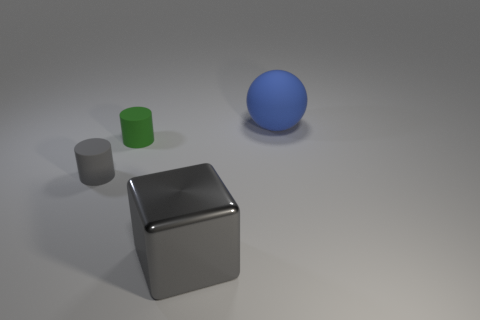Imagine these objects are part of a learning kit, what might be the purpose of this kit? If these objects are part of a learning kit, they could be used to help teach fundamental concepts such as geometry, understanding three-dimensional shapes, color recognition, and spatial reasoning. The kit can demonstrate how geometric forms are constructed and how they interact in real-life physics, like stacking or rolling. 